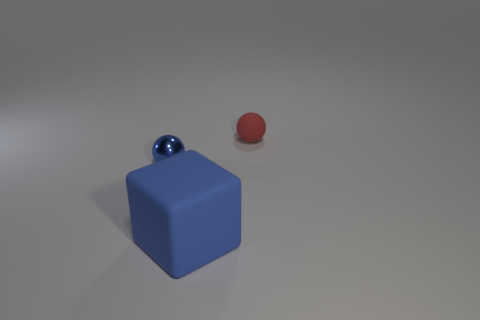Add 2 large rubber blocks. How many objects exist? 5 Subtract all balls. How many objects are left? 1 Subtract all matte things. Subtract all tiny purple metallic cubes. How many objects are left? 1 Add 2 big cubes. How many big cubes are left? 3 Add 3 small blue metal spheres. How many small blue metal spheres exist? 4 Subtract 0 yellow spheres. How many objects are left? 3 